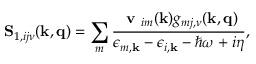<formula> <loc_0><loc_0><loc_500><loc_500>S _ { 1 , i j \nu } ( k , \mathbf { q } ) = \sum _ { m } \frac { v _ { i m } ( k ) g _ { m j , \nu } ( k , q ) } { \epsilon _ { m , k } - \epsilon _ { i , k } - \hbar { \omega } + i \eta } ,</formula> 